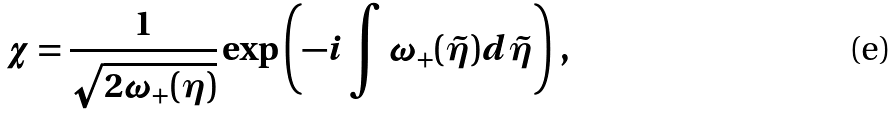<formula> <loc_0><loc_0><loc_500><loc_500>\chi = \frac { 1 } { \sqrt { 2 \omega _ { + } ( \eta ) } } \exp \left ( - i \int \omega _ { + } ( \tilde { \eta } ) d \tilde { \eta } \right ) \, ,</formula> 